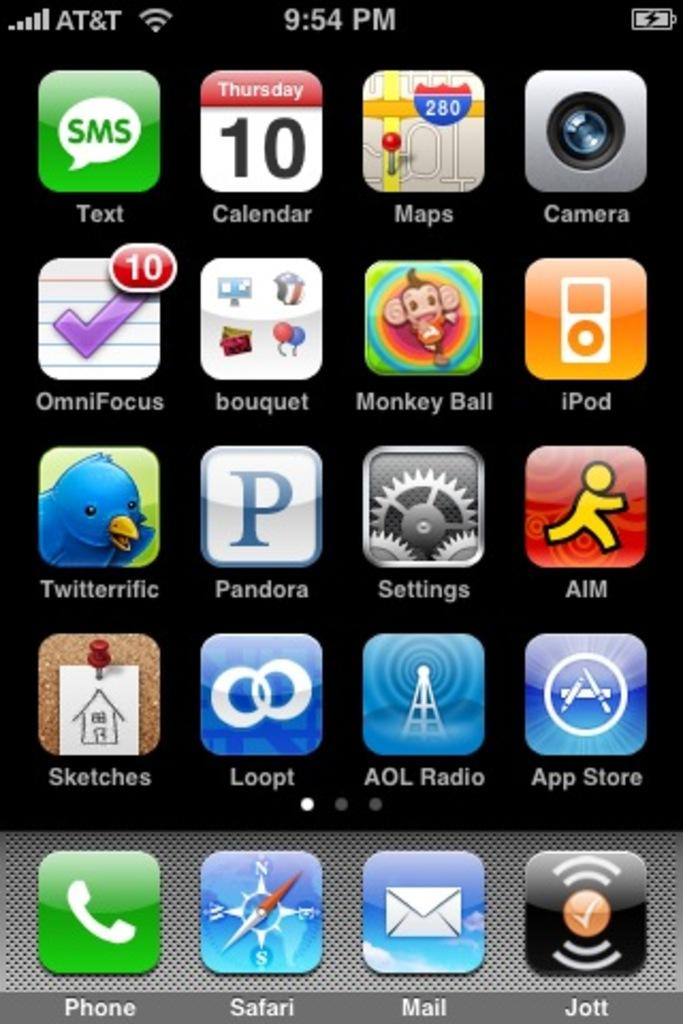<image>
Create a compact narrative representing the image presented. A screenshot from an AT&T phone on a page full of apps. 